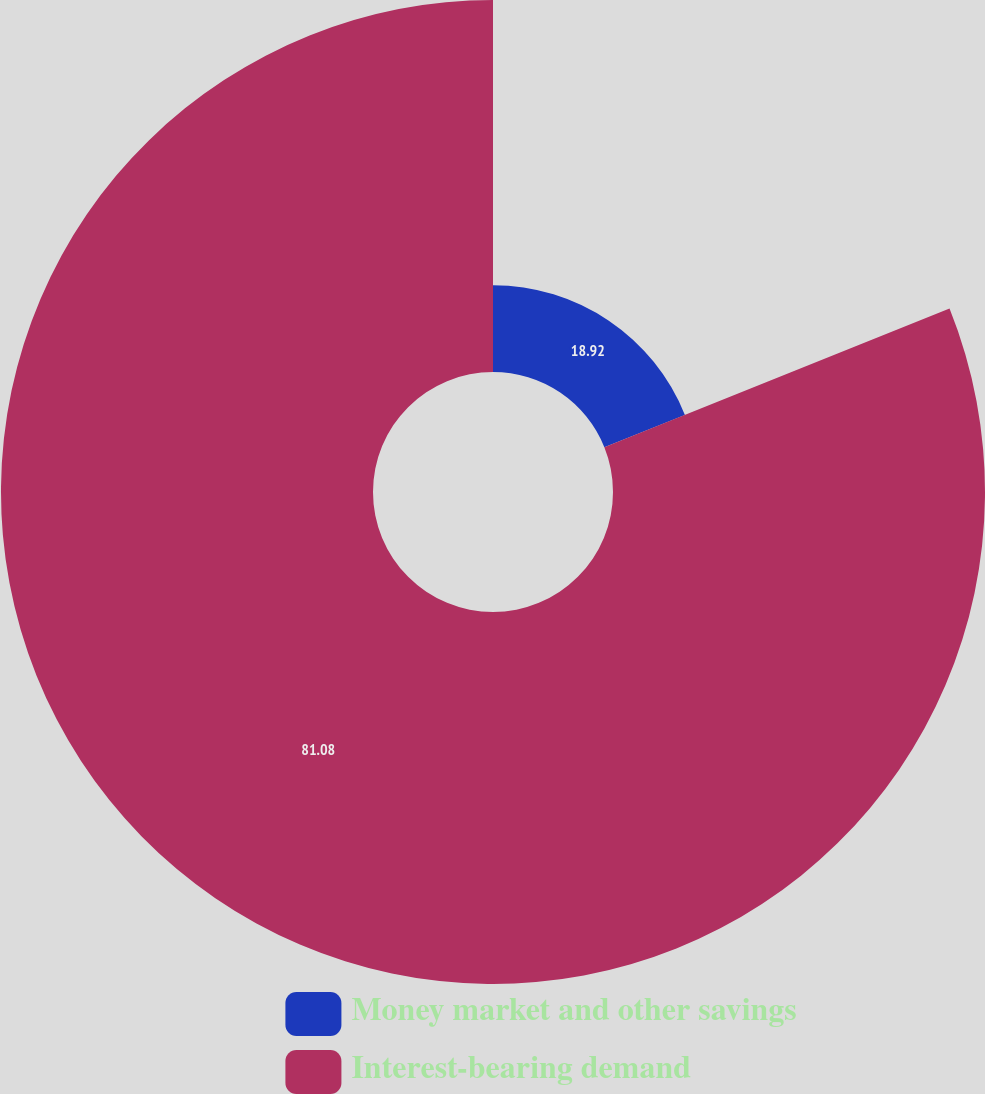Convert chart. <chart><loc_0><loc_0><loc_500><loc_500><pie_chart><fcel>Money market and other savings<fcel>Interest-bearing demand<nl><fcel>18.92%<fcel>81.08%<nl></chart> 